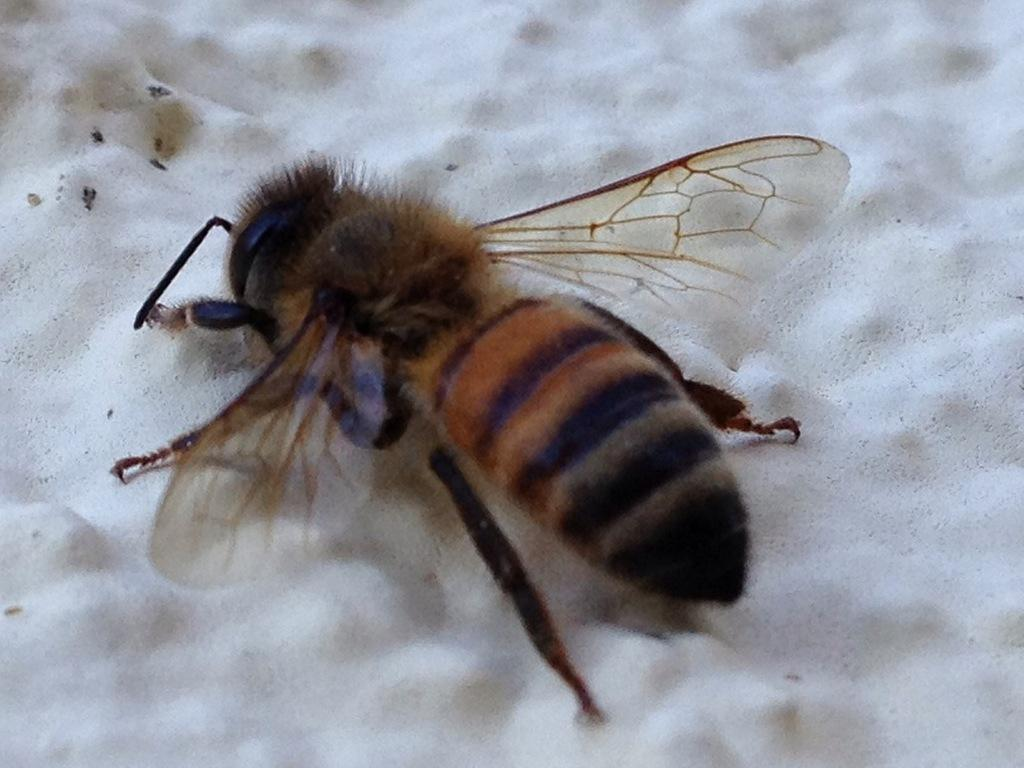What type of creature is present in the image? There is an insect in the image. What is the background or surface on which the insect is located? The insect is on a white surface. How many aunts are visible in the image? There are no aunts present in the image; it features an insect on a white surface. What type of birds can be seen flying in the image? There are no birds present in the image; it features an insect on a white surface. 